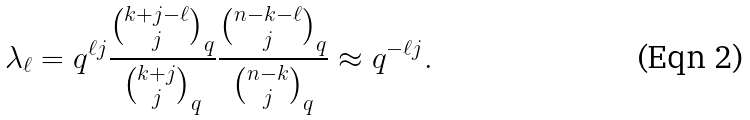<formula> <loc_0><loc_0><loc_500><loc_500>\lambda _ { \ell } = q ^ { \ell j } \frac { { k + j - \ell \choose j } _ { q } } { { k + j \choose j } _ { q } } \frac { { n - k - \ell \choose j } _ { q } } { { n - k \choose j } _ { q } } \approx q ^ { - \ell j } .</formula> 